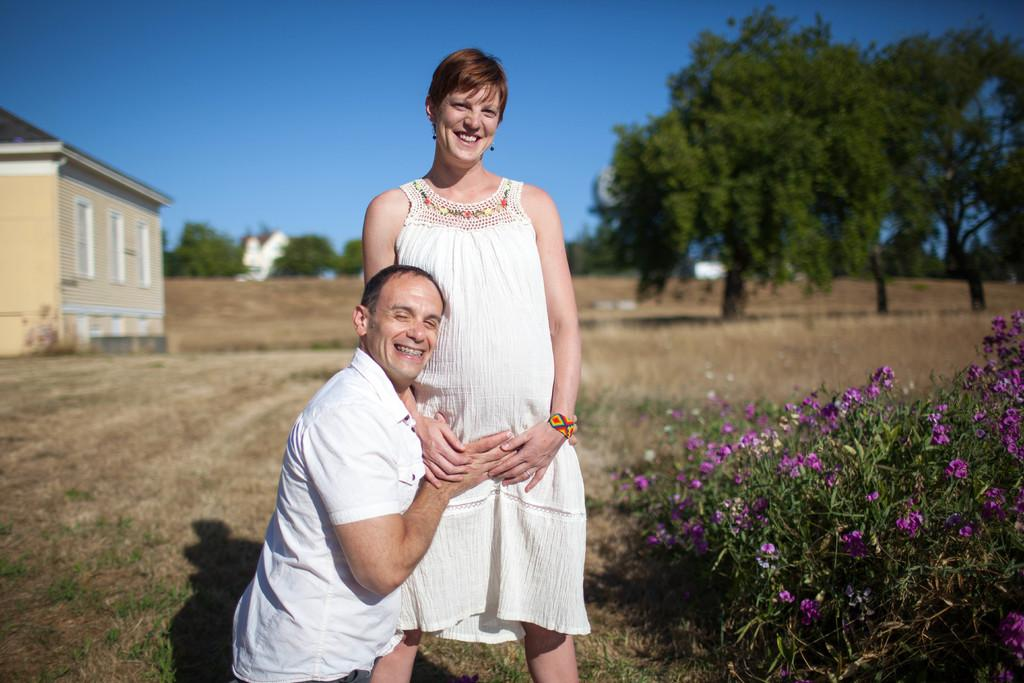What types of living organisms can be seen in the image? Plants and flowers are visible in the image. What type of structure is present in the image? There is a house in the image. What other natural elements can be seen in the image? Trees are present in the image. What is visible at the top of the image? The sky is visible at the top of the image. How many people are in the image, and what are they wearing? There are two persons in the image, and they are both wearing white color dresses. Where is the mailbox located in the image? There is no mailbox present in the image. What type of needle is being used by the person in the image? There are no needles present in the image. What type of soap is being used by the person in the image? There is no soap present in the image. 